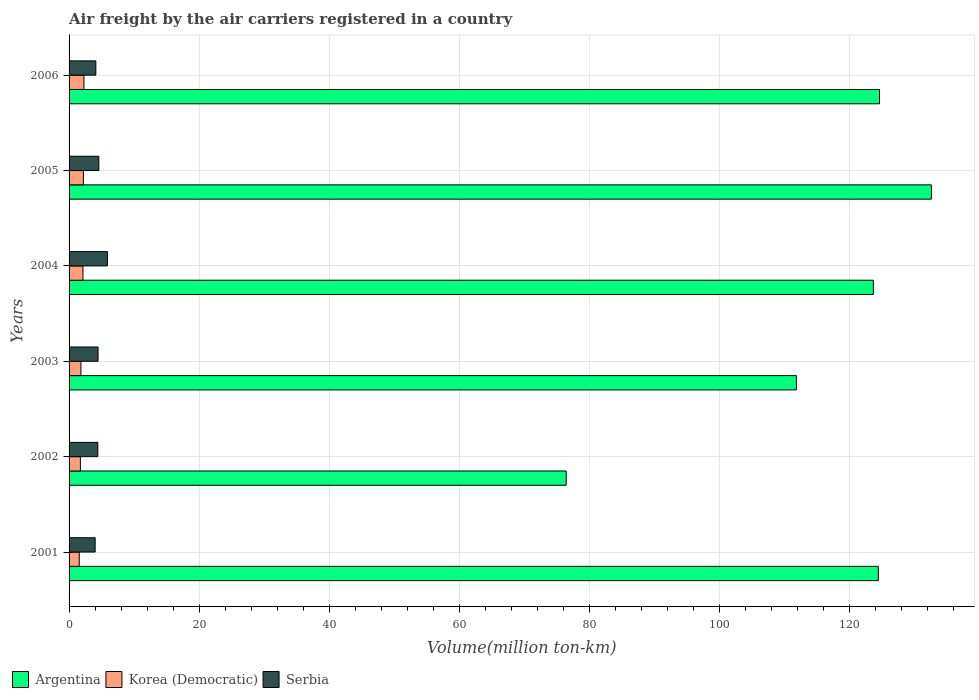Are the number of bars on each tick of the Y-axis equal?
Provide a short and direct response. Yes. How many bars are there on the 5th tick from the top?
Ensure brevity in your answer.  3. What is the label of the 6th group of bars from the top?
Your response must be concise. 2001. What is the volume of the air carriers in Korea (Democratic) in 2001?
Ensure brevity in your answer.  1.56. Across all years, what is the maximum volume of the air carriers in Argentina?
Offer a terse response. 132.56. Across all years, what is the minimum volume of the air carriers in Serbia?
Keep it short and to the point. 4.01. In which year was the volume of the air carriers in Argentina maximum?
Ensure brevity in your answer.  2005. What is the total volume of the air carriers in Argentina in the graph?
Your response must be concise. 693.41. What is the difference between the volume of the air carriers in Korea (Democratic) in 2003 and that in 2006?
Ensure brevity in your answer.  -0.46. What is the difference between the volume of the air carriers in Argentina in 2003 and the volume of the air carriers in Serbia in 2002?
Make the answer very short. 107.39. What is the average volume of the air carriers in Korea (Democratic) per year?
Your answer should be compact. 1.96. In the year 2003, what is the difference between the volume of the air carriers in Serbia and volume of the air carriers in Korea (Democratic)?
Provide a succinct answer. 2.63. In how many years, is the volume of the air carriers in Serbia greater than 116 million ton-km?
Your response must be concise. 0. What is the ratio of the volume of the air carriers in Serbia in 2001 to that in 2004?
Offer a terse response. 0.68. What is the difference between the highest and the second highest volume of the air carriers in Serbia?
Ensure brevity in your answer.  1.31. What is the difference between the highest and the lowest volume of the air carriers in Serbia?
Offer a terse response. 1.88. In how many years, is the volume of the air carriers in Korea (Democratic) greater than the average volume of the air carriers in Korea (Democratic) taken over all years?
Provide a short and direct response. 3. What does the 1st bar from the top in 2003 represents?
Offer a terse response. Serbia. What does the 2nd bar from the bottom in 2001 represents?
Provide a succinct answer. Korea (Democratic). Is it the case that in every year, the sum of the volume of the air carriers in Serbia and volume of the air carriers in Argentina is greater than the volume of the air carriers in Korea (Democratic)?
Give a very brief answer. Yes. Are all the bars in the graph horizontal?
Make the answer very short. Yes. How many years are there in the graph?
Make the answer very short. 6. What is the difference between two consecutive major ticks on the X-axis?
Offer a very short reply. 20. Are the values on the major ticks of X-axis written in scientific E-notation?
Offer a very short reply. No. Does the graph contain grids?
Your answer should be very brief. Yes. How many legend labels are there?
Your answer should be very brief. 3. How are the legend labels stacked?
Give a very brief answer. Horizontal. What is the title of the graph?
Provide a short and direct response. Air freight by the air carriers registered in a country. Does "Equatorial Guinea" appear as one of the legend labels in the graph?
Your answer should be compact. No. What is the label or title of the X-axis?
Provide a short and direct response. Volume(million ton-km). What is the Volume(million ton-km) in Argentina in 2001?
Make the answer very short. 124.4. What is the Volume(million ton-km) in Korea (Democratic) in 2001?
Your response must be concise. 1.56. What is the Volume(million ton-km) of Serbia in 2001?
Your answer should be very brief. 4.01. What is the Volume(million ton-km) of Argentina in 2002?
Keep it short and to the point. 76.42. What is the Volume(million ton-km) of Korea (Democratic) in 2002?
Keep it short and to the point. 1.74. What is the Volume(million ton-km) of Serbia in 2002?
Make the answer very short. 4.42. What is the Volume(million ton-km) of Argentina in 2003?
Keep it short and to the point. 111.81. What is the Volume(million ton-km) of Korea (Democratic) in 2003?
Your response must be concise. 1.82. What is the Volume(million ton-km) in Serbia in 2003?
Your response must be concise. 4.45. What is the Volume(million ton-km) in Argentina in 2004?
Your answer should be very brief. 123.64. What is the Volume(million ton-km) of Korea (Democratic) in 2004?
Keep it short and to the point. 2.13. What is the Volume(million ton-km) of Serbia in 2004?
Offer a very short reply. 5.89. What is the Volume(million ton-km) in Argentina in 2005?
Your answer should be compact. 132.56. What is the Volume(million ton-km) of Korea (Democratic) in 2005?
Your answer should be compact. 2.2. What is the Volume(million ton-km) in Serbia in 2005?
Your response must be concise. 4.58. What is the Volume(million ton-km) of Argentina in 2006?
Make the answer very short. 124.58. What is the Volume(million ton-km) in Korea (Democratic) in 2006?
Your answer should be very brief. 2.29. What is the Volume(million ton-km) in Serbia in 2006?
Offer a very short reply. 4.11. Across all years, what is the maximum Volume(million ton-km) of Argentina?
Offer a terse response. 132.56. Across all years, what is the maximum Volume(million ton-km) in Korea (Democratic)?
Make the answer very short. 2.29. Across all years, what is the maximum Volume(million ton-km) of Serbia?
Keep it short and to the point. 5.89. Across all years, what is the minimum Volume(million ton-km) of Argentina?
Provide a short and direct response. 76.42. Across all years, what is the minimum Volume(million ton-km) of Korea (Democratic)?
Your response must be concise. 1.56. Across all years, what is the minimum Volume(million ton-km) in Serbia?
Make the answer very short. 4.01. What is the total Volume(million ton-km) in Argentina in the graph?
Give a very brief answer. 693.41. What is the total Volume(million ton-km) of Korea (Democratic) in the graph?
Your answer should be compact. 11.74. What is the total Volume(million ton-km) of Serbia in the graph?
Keep it short and to the point. 27.46. What is the difference between the Volume(million ton-km) of Argentina in 2001 and that in 2002?
Keep it short and to the point. 47.98. What is the difference between the Volume(million ton-km) in Korea (Democratic) in 2001 and that in 2002?
Your response must be concise. -0.17. What is the difference between the Volume(million ton-km) of Serbia in 2001 and that in 2002?
Give a very brief answer. -0.41. What is the difference between the Volume(million ton-km) of Argentina in 2001 and that in 2003?
Make the answer very short. 12.59. What is the difference between the Volume(million ton-km) of Korea (Democratic) in 2001 and that in 2003?
Keep it short and to the point. -0.26. What is the difference between the Volume(million ton-km) of Serbia in 2001 and that in 2003?
Your response must be concise. -0.45. What is the difference between the Volume(million ton-km) in Argentina in 2001 and that in 2004?
Offer a very short reply. 0.77. What is the difference between the Volume(million ton-km) in Korea (Democratic) in 2001 and that in 2004?
Keep it short and to the point. -0.57. What is the difference between the Volume(million ton-km) of Serbia in 2001 and that in 2004?
Your answer should be very brief. -1.88. What is the difference between the Volume(million ton-km) of Argentina in 2001 and that in 2005?
Make the answer very short. -8.16. What is the difference between the Volume(million ton-km) in Korea (Democratic) in 2001 and that in 2005?
Keep it short and to the point. -0.63. What is the difference between the Volume(million ton-km) in Serbia in 2001 and that in 2005?
Your answer should be compact. -0.57. What is the difference between the Volume(million ton-km) of Argentina in 2001 and that in 2006?
Provide a succinct answer. -0.18. What is the difference between the Volume(million ton-km) in Korea (Democratic) in 2001 and that in 2006?
Offer a very short reply. -0.72. What is the difference between the Volume(million ton-km) in Serbia in 2001 and that in 2006?
Provide a succinct answer. -0.11. What is the difference between the Volume(million ton-km) in Argentina in 2002 and that in 2003?
Provide a short and direct response. -35.39. What is the difference between the Volume(million ton-km) in Korea (Democratic) in 2002 and that in 2003?
Your response must be concise. -0.09. What is the difference between the Volume(million ton-km) in Serbia in 2002 and that in 2003?
Give a very brief answer. -0.04. What is the difference between the Volume(million ton-km) in Argentina in 2002 and that in 2004?
Provide a short and direct response. -47.22. What is the difference between the Volume(million ton-km) of Korea (Democratic) in 2002 and that in 2004?
Offer a terse response. -0.4. What is the difference between the Volume(million ton-km) in Serbia in 2002 and that in 2004?
Give a very brief answer. -1.47. What is the difference between the Volume(million ton-km) in Argentina in 2002 and that in 2005?
Keep it short and to the point. -56.14. What is the difference between the Volume(million ton-km) of Korea (Democratic) in 2002 and that in 2005?
Offer a terse response. -0.46. What is the difference between the Volume(million ton-km) of Serbia in 2002 and that in 2005?
Provide a short and direct response. -0.16. What is the difference between the Volume(million ton-km) of Argentina in 2002 and that in 2006?
Offer a very short reply. -48.16. What is the difference between the Volume(million ton-km) in Korea (Democratic) in 2002 and that in 2006?
Your answer should be compact. -0.55. What is the difference between the Volume(million ton-km) in Serbia in 2002 and that in 2006?
Your answer should be very brief. 0.3. What is the difference between the Volume(million ton-km) in Argentina in 2003 and that in 2004?
Make the answer very short. -11.83. What is the difference between the Volume(million ton-km) of Korea (Democratic) in 2003 and that in 2004?
Provide a short and direct response. -0.31. What is the difference between the Volume(million ton-km) of Serbia in 2003 and that in 2004?
Ensure brevity in your answer.  -1.44. What is the difference between the Volume(million ton-km) in Argentina in 2003 and that in 2005?
Ensure brevity in your answer.  -20.75. What is the difference between the Volume(million ton-km) of Korea (Democratic) in 2003 and that in 2005?
Make the answer very short. -0.37. What is the difference between the Volume(million ton-km) in Serbia in 2003 and that in 2005?
Give a very brief answer. -0.12. What is the difference between the Volume(million ton-km) in Argentina in 2003 and that in 2006?
Provide a succinct answer. -12.77. What is the difference between the Volume(million ton-km) of Korea (Democratic) in 2003 and that in 2006?
Provide a short and direct response. -0.46. What is the difference between the Volume(million ton-km) of Serbia in 2003 and that in 2006?
Your answer should be very brief. 0.34. What is the difference between the Volume(million ton-km) in Argentina in 2004 and that in 2005?
Make the answer very short. -8.92. What is the difference between the Volume(million ton-km) in Korea (Democratic) in 2004 and that in 2005?
Your answer should be very brief. -0.06. What is the difference between the Volume(million ton-km) of Serbia in 2004 and that in 2005?
Make the answer very short. 1.31. What is the difference between the Volume(million ton-km) of Argentina in 2004 and that in 2006?
Keep it short and to the point. -0.95. What is the difference between the Volume(million ton-km) in Korea (Democratic) in 2004 and that in 2006?
Your answer should be compact. -0.15. What is the difference between the Volume(million ton-km) in Serbia in 2004 and that in 2006?
Provide a short and direct response. 1.78. What is the difference between the Volume(million ton-km) of Argentina in 2005 and that in 2006?
Give a very brief answer. 7.97. What is the difference between the Volume(million ton-km) in Korea (Democratic) in 2005 and that in 2006?
Keep it short and to the point. -0.09. What is the difference between the Volume(million ton-km) in Serbia in 2005 and that in 2006?
Provide a succinct answer. 0.46. What is the difference between the Volume(million ton-km) of Argentina in 2001 and the Volume(million ton-km) of Korea (Democratic) in 2002?
Your answer should be compact. 122.67. What is the difference between the Volume(million ton-km) in Argentina in 2001 and the Volume(million ton-km) in Serbia in 2002?
Ensure brevity in your answer.  119.98. What is the difference between the Volume(million ton-km) of Korea (Democratic) in 2001 and the Volume(million ton-km) of Serbia in 2002?
Keep it short and to the point. -2.85. What is the difference between the Volume(million ton-km) of Argentina in 2001 and the Volume(million ton-km) of Korea (Democratic) in 2003?
Give a very brief answer. 122.58. What is the difference between the Volume(million ton-km) in Argentina in 2001 and the Volume(million ton-km) in Serbia in 2003?
Offer a very short reply. 119.95. What is the difference between the Volume(million ton-km) of Korea (Democratic) in 2001 and the Volume(million ton-km) of Serbia in 2003?
Your response must be concise. -2.89. What is the difference between the Volume(million ton-km) in Argentina in 2001 and the Volume(million ton-km) in Korea (Democratic) in 2004?
Your answer should be very brief. 122.27. What is the difference between the Volume(million ton-km) of Argentina in 2001 and the Volume(million ton-km) of Serbia in 2004?
Your response must be concise. 118.51. What is the difference between the Volume(million ton-km) in Korea (Democratic) in 2001 and the Volume(million ton-km) in Serbia in 2004?
Give a very brief answer. -4.33. What is the difference between the Volume(million ton-km) in Argentina in 2001 and the Volume(million ton-km) in Korea (Democratic) in 2005?
Provide a short and direct response. 122.2. What is the difference between the Volume(million ton-km) of Argentina in 2001 and the Volume(million ton-km) of Serbia in 2005?
Give a very brief answer. 119.82. What is the difference between the Volume(million ton-km) in Korea (Democratic) in 2001 and the Volume(million ton-km) in Serbia in 2005?
Offer a terse response. -3.01. What is the difference between the Volume(million ton-km) in Argentina in 2001 and the Volume(million ton-km) in Korea (Democratic) in 2006?
Ensure brevity in your answer.  122.12. What is the difference between the Volume(million ton-km) in Argentina in 2001 and the Volume(million ton-km) in Serbia in 2006?
Offer a very short reply. 120.29. What is the difference between the Volume(million ton-km) in Korea (Democratic) in 2001 and the Volume(million ton-km) in Serbia in 2006?
Your answer should be very brief. -2.55. What is the difference between the Volume(million ton-km) of Argentina in 2002 and the Volume(million ton-km) of Korea (Democratic) in 2003?
Ensure brevity in your answer.  74.59. What is the difference between the Volume(million ton-km) of Argentina in 2002 and the Volume(million ton-km) of Serbia in 2003?
Your answer should be very brief. 71.97. What is the difference between the Volume(million ton-km) in Korea (Democratic) in 2002 and the Volume(million ton-km) in Serbia in 2003?
Keep it short and to the point. -2.72. What is the difference between the Volume(million ton-km) in Argentina in 2002 and the Volume(million ton-km) in Korea (Democratic) in 2004?
Offer a terse response. 74.28. What is the difference between the Volume(million ton-km) in Argentina in 2002 and the Volume(million ton-km) in Serbia in 2004?
Make the answer very short. 70.53. What is the difference between the Volume(million ton-km) in Korea (Democratic) in 2002 and the Volume(million ton-km) in Serbia in 2004?
Your response must be concise. -4.16. What is the difference between the Volume(million ton-km) in Argentina in 2002 and the Volume(million ton-km) in Korea (Democratic) in 2005?
Your response must be concise. 74.22. What is the difference between the Volume(million ton-km) in Argentina in 2002 and the Volume(million ton-km) in Serbia in 2005?
Your answer should be very brief. 71.84. What is the difference between the Volume(million ton-km) of Korea (Democratic) in 2002 and the Volume(million ton-km) of Serbia in 2005?
Ensure brevity in your answer.  -2.84. What is the difference between the Volume(million ton-km) in Argentina in 2002 and the Volume(million ton-km) in Korea (Democratic) in 2006?
Offer a very short reply. 74.13. What is the difference between the Volume(million ton-km) of Argentina in 2002 and the Volume(million ton-km) of Serbia in 2006?
Your answer should be compact. 72.31. What is the difference between the Volume(million ton-km) of Korea (Democratic) in 2002 and the Volume(million ton-km) of Serbia in 2006?
Your answer should be compact. -2.38. What is the difference between the Volume(million ton-km) of Argentina in 2003 and the Volume(million ton-km) of Korea (Democratic) in 2004?
Give a very brief answer. 109.68. What is the difference between the Volume(million ton-km) of Argentina in 2003 and the Volume(million ton-km) of Serbia in 2004?
Keep it short and to the point. 105.92. What is the difference between the Volume(million ton-km) of Korea (Democratic) in 2003 and the Volume(million ton-km) of Serbia in 2004?
Give a very brief answer. -4.07. What is the difference between the Volume(million ton-km) of Argentina in 2003 and the Volume(million ton-km) of Korea (Democratic) in 2005?
Offer a terse response. 109.61. What is the difference between the Volume(million ton-km) in Argentina in 2003 and the Volume(million ton-km) in Serbia in 2005?
Your answer should be very brief. 107.23. What is the difference between the Volume(million ton-km) of Korea (Democratic) in 2003 and the Volume(million ton-km) of Serbia in 2005?
Make the answer very short. -2.75. What is the difference between the Volume(million ton-km) in Argentina in 2003 and the Volume(million ton-km) in Korea (Democratic) in 2006?
Provide a short and direct response. 109.53. What is the difference between the Volume(million ton-km) in Argentina in 2003 and the Volume(million ton-km) in Serbia in 2006?
Provide a short and direct response. 107.7. What is the difference between the Volume(million ton-km) of Korea (Democratic) in 2003 and the Volume(million ton-km) of Serbia in 2006?
Offer a very short reply. -2.29. What is the difference between the Volume(million ton-km) in Argentina in 2004 and the Volume(million ton-km) in Korea (Democratic) in 2005?
Offer a very short reply. 121.44. What is the difference between the Volume(million ton-km) in Argentina in 2004 and the Volume(million ton-km) in Serbia in 2005?
Provide a short and direct response. 119.06. What is the difference between the Volume(million ton-km) in Korea (Democratic) in 2004 and the Volume(million ton-km) in Serbia in 2005?
Keep it short and to the point. -2.44. What is the difference between the Volume(million ton-km) in Argentina in 2004 and the Volume(million ton-km) in Korea (Democratic) in 2006?
Your response must be concise. 121.35. What is the difference between the Volume(million ton-km) of Argentina in 2004 and the Volume(million ton-km) of Serbia in 2006?
Ensure brevity in your answer.  119.52. What is the difference between the Volume(million ton-km) of Korea (Democratic) in 2004 and the Volume(million ton-km) of Serbia in 2006?
Give a very brief answer. -1.98. What is the difference between the Volume(million ton-km) of Argentina in 2005 and the Volume(million ton-km) of Korea (Democratic) in 2006?
Ensure brevity in your answer.  130.27. What is the difference between the Volume(million ton-km) in Argentina in 2005 and the Volume(million ton-km) in Serbia in 2006?
Keep it short and to the point. 128.44. What is the difference between the Volume(million ton-km) in Korea (Democratic) in 2005 and the Volume(million ton-km) in Serbia in 2006?
Ensure brevity in your answer.  -1.92. What is the average Volume(million ton-km) in Argentina per year?
Offer a terse response. 115.57. What is the average Volume(million ton-km) in Korea (Democratic) per year?
Make the answer very short. 1.96. What is the average Volume(million ton-km) in Serbia per year?
Offer a terse response. 4.58. In the year 2001, what is the difference between the Volume(million ton-km) in Argentina and Volume(million ton-km) in Korea (Democratic)?
Keep it short and to the point. 122.84. In the year 2001, what is the difference between the Volume(million ton-km) in Argentina and Volume(million ton-km) in Serbia?
Provide a short and direct response. 120.39. In the year 2001, what is the difference between the Volume(million ton-km) of Korea (Democratic) and Volume(million ton-km) of Serbia?
Offer a very short reply. -2.44. In the year 2002, what is the difference between the Volume(million ton-km) of Argentina and Volume(million ton-km) of Korea (Democratic)?
Provide a succinct answer. 74.68. In the year 2002, what is the difference between the Volume(million ton-km) of Argentina and Volume(million ton-km) of Serbia?
Provide a succinct answer. 72. In the year 2002, what is the difference between the Volume(million ton-km) of Korea (Democratic) and Volume(million ton-km) of Serbia?
Offer a terse response. -2.68. In the year 2003, what is the difference between the Volume(million ton-km) in Argentina and Volume(million ton-km) in Korea (Democratic)?
Provide a short and direct response. 109.99. In the year 2003, what is the difference between the Volume(million ton-km) in Argentina and Volume(million ton-km) in Serbia?
Give a very brief answer. 107.36. In the year 2003, what is the difference between the Volume(million ton-km) in Korea (Democratic) and Volume(million ton-km) in Serbia?
Ensure brevity in your answer.  -2.63. In the year 2004, what is the difference between the Volume(million ton-km) in Argentina and Volume(million ton-km) in Korea (Democratic)?
Offer a terse response. 121.5. In the year 2004, what is the difference between the Volume(million ton-km) in Argentina and Volume(million ton-km) in Serbia?
Provide a short and direct response. 117.75. In the year 2004, what is the difference between the Volume(million ton-km) of Korea (Democratic) and Volume(million ton-km) of Serbia?
Provide a short and direct response. -3.76. In the year 2005, what is the difference between the Volume(million ton-km) in Argentina and Volume(million ton-km) in Korea (Democratic)?
Provide a short and direct response. 130.36. In the year 2005, what is the difference between the Volume(million ton-km) in Argentina and Volume(million ton-km) in Serbia?
Offer a very short reply. 127.98. In the year 2005, what is the difference between the Volume(million ton-km) of Korea (Democratic) and Volume(million ton-km) of Serbia?
Your answer should be very brief. -2.38. In the year 2006, what is the difference between the Volume(million ton-km) of Argentina and Volume(million ton-km) of Korea (Democratic)?
Offer a terse response. 122.3. In the year 2006, what is the difference between the Volume(million ton-km) of Argentina and Volume(million ton-km) of Serbia?
Ensure brevity in your answer.  120.47. In the year 2006, what is the difference between the Volume(million ton-km) of Korea (Democratic) and Volume(million ton-km) of Serbia?
Keep it short and to the point. -1.83. What is the ratio of the Volume(million ton-km) in Argentina in 2001 to that in 2002?
Your answer should be compact. 1.63. What is the ratio of the Volume(million ton-km) of Korea (Democratic) in 2001 to that in 2002?
Offer a terse response. 0.9. What is the ratio of the Volume(million ton-km) in Serbia in 2001 to that in 2002?
Offer a very short reply. 0.91. What is the ratio of the Volume(million ton-km) in Argentina in 2001 to that in 2003?
Keep it short and to the point. 1.11. What is the ratio of the Volume(million ton-km) of Korea (Democratic) in 2001 to that in 2003?
Ensure brevity in your answer.  0.86. What is the ratio of the Volume(million ton-km) of Serbia in 2001 to that in 2003?
Make the answer very short. 0.9. What is the ratio of the Volume(million ton-km) of Argentina in 2001 to that in 2004?
Make the answer very short. 1.01. What is the ratio of the Volume(million ton-km) of Korea (Democratic) in 2001 to that in 2004?
Offer a very short reply. 0.73. What is the ratio of the Volume(million ton-km) of Serbia in 2001 to that in 2004?
Your response must be concise. 0.68. What is the ratio of the Volume(million ton-km) in Argentina in 2001 to that in 2005?
Your answer should be compact. 0.94. What is the ratio of the Volume(million ton-km) of Korea (Democratic) in 2001 to that in 2005?
Ensure brevity in your answer.  0.71. What is the ratio of the Volume(million ton-km) of Serbia in 2001 to that in 2005?
Your response must be concise. 0.88. What is the ratio of the Volume(million ton-km) of Argentina in 2001 to that in 2006?
Your response must be concise. 1. What is the ratio of the Volume(million ton-km) of Korea (Democratic) in 2001 to that in 2006?
Your response must be concise. 0.68. What is the ratio of the Volume(million ton-km) of Serbia in 2001 to that in 2006?
Offer a terse response. 0.97. What is the ratio of the Volume(million ton-km) in Argentina in 2002 to that in 2003?
Provide a succinct answer. 0.68. What is the ratio of the Volume(million ton-km) in Korea (Democratic) in 2002 to that in 2003?
Ensure brevity in your answer.  0.95. What is the ratio of the Volume(million ton-km) of Serbia in 2002 to that in 2003?
Offer a very short reply. 0.99. What is the ratio of the Volume(million ton-km) in Argentina in 2002 to that in 2004?
Make the answer very short. 0.62. What is the ratio of the Volume(million ton-km) in Korea (Democratic) in 2002 to that in 2004?
Offer a very short reply. 0.81. What is the ratio of the Volume(million ton-km) of Serbia in 2002 to that in 2004?
Ensure brevity in your answer.  0.75. What is the ratio of the Volume(million ton-km) in Argentina in 2002 to that in 2005?
Your answer should be very brief. 0.58. What is the ratio of the Volume(million ton-km) of Korea (Democratic) in 2002 to that in 2005?
Offer a very short reply. 0.79. What is the ratio of the Volume(million ton-km) in Serbia in 2002 to that in 2005?
Your response must be concise. 0.97. What is the ratio of the Volume(million ton-km) in Argentina in 2002 to that in 2006?
Provide a short and direct response. 0.61. What is the ratio of the Volume(million ton-km) in Korea (Democratic) in 2002 to that in 2006?
Your answer should be very brief. 0.76. What is the ratio of the Volume(million ton-km) of Serbia in 2002 to that in 2006?
Your answer should be very brief. 1.07. What is the ratio of the Volume(million ton-km) in Argentina in 2003 to that in 2004?
Provide a succinct answer. 0.9. What is the ratio of the Volume(million ton-km) in Korea (Democratic) in 2003 to that in 2004?
Your response must be concise. 0.85. What is the ratio of the Volume(million ton-km) in Serbia in 2003 to that in 2004?
Provide a succinct answer. 0.76. What is the ratio of the Volume(million ton-km) of Argentina in 2003 to that in 2005?
Offer a terse response. 0.84. What is the ratio of the Volume(million ton-km) of Korea (Democratic) in 2003 to that in 2005?
Offer a very short reply. 0.83. What is the ratio of the Volume(million ton-km) in Serbia in 2003 to that in 2005?
Your response must be concise. 0.97. What is the ratio of the Volume(million ton-km) of Argentina in 2003 to that in 2006?
Give a very brief answer. 0.9. What is the ratio of the Volume(million ton-km) of Korea (Democratic) in 2003 to that in 2006?
Your response must be concise. 0.8. What is the ratio of the Volume(million ton-km) in Serbia in 2003 to that in 2006?
Offer a very short reply. 1.08. What is the ratio of the Volume(million ton-km) of Argentina in 2004 to that in 2005?
Your answer should be compact. 0.93. What is the ratio of the Volume(million ton-km) of Korea (Democratic) in 2004 to that in 2005?
Give a very brief answer. 0.97. What is the ratio of the Volume(million ton-km) of Serbia in 2004 to that in 2005?
Offer a terse response. 1.29. What is the ratio of the Volume(million ton-km) in Argentina in 2004 to that in 2006?
Give a very brief answer. 0.99. What is the ratio of the Volume(million ton-km) in Korea (Democratic) in 2004 to that in 2006?
Your response must be concise. 0.93. What is the ratio of the Volume(million ton-km) of Serbia in 2004 to that in 2006?
Your answer should be compact. 1.43. What is the ratio of the Volume(million ton-km) in Argentina in 2005 to that in 2006?
Offer a terse response. 1.06. What is the ratio of the Volume(million ton-km) of Korea (Democratic) in 2005 to that in 2006?
Offer a very short reply. 0.96. What is the ratio of the Volume(million ton-km) of Serbia in 2005 to that in 2006?
Offer a terse response. 1.11. What is the difference between the highest and the second highest Volume(million ton-km) in Argentina?
Make the answer very short. 7.97. What is the difference between the highest and the second highest Volume(million ton-km) of Korea (Democratic)?
Provide a succinct answer. 0.09. What is the difference between the highest and the second highest Volume(million ton-km) of Serbia?
Your response must be concise. 1.31. What is the difference between the highest and the lowest Volume(million ton-km) in Argentina?
Your answer should be very brief. 56.14. What is the difference between the highest and the lowest Volume(million ton-km) in Korea (Democratic)?
Your answer should be very brief. 0.72. What is the difference between the highest and the lowest Volume(million ton-km) in Serbia?
Provide a short and direct response. 1.88. 